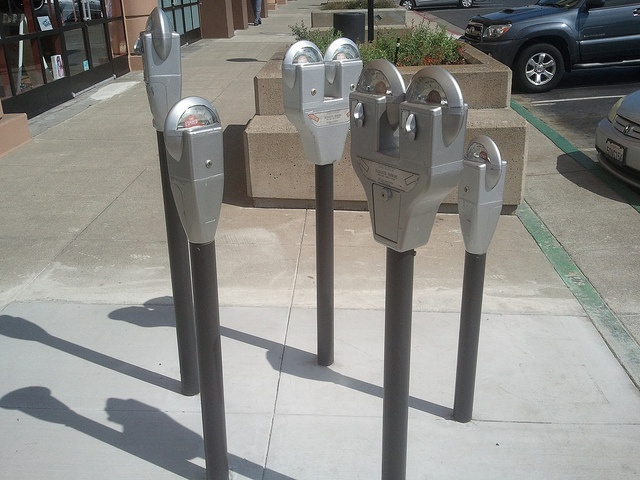Describe the objects in this image and their specific colors. I can see parking meter in black and gray tones, car in black, gray, blue, and navy tones, parking meter in black, darkgray, gray, and lightgray tones, parking meter in black, gray, darkgray, and lightgray tones, and parking meter in black and gray tones in this image. 